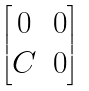<formula> <loc_0><loc_0><loc_500><loc_500>\begin{bmatrix} 0 & 0 \\ C & 0 \end{bmatrix}</formula> 